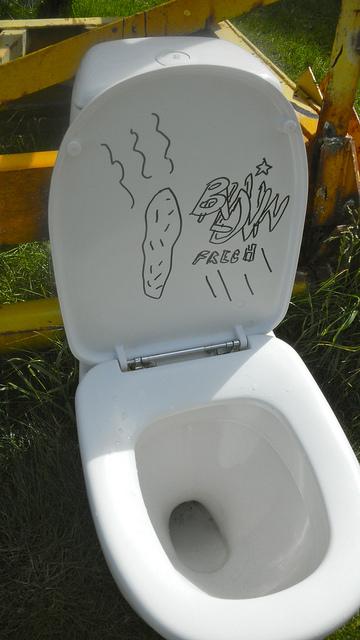Is there graffiti on this toilet?
Be succinct. Yes. What is the color of the toilet?
Concise answer only. White. Is the toilet lid up?
Answer briefly. Yes. 